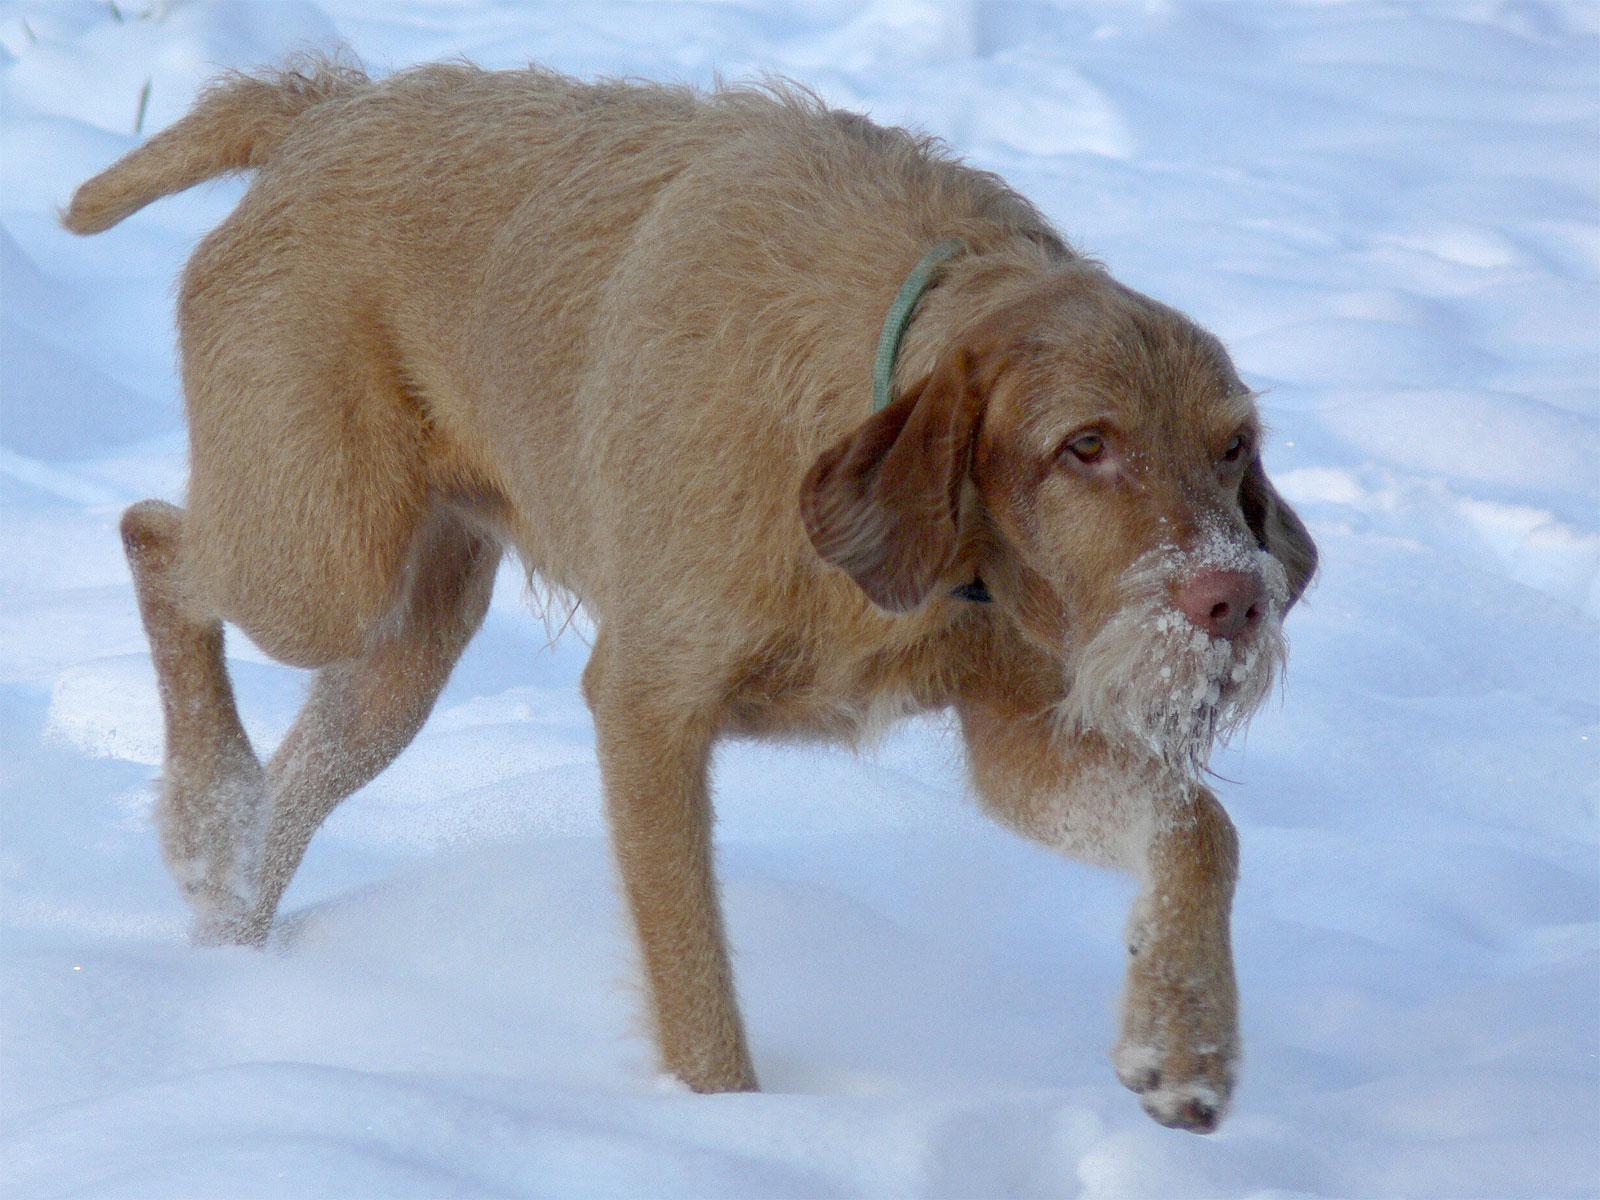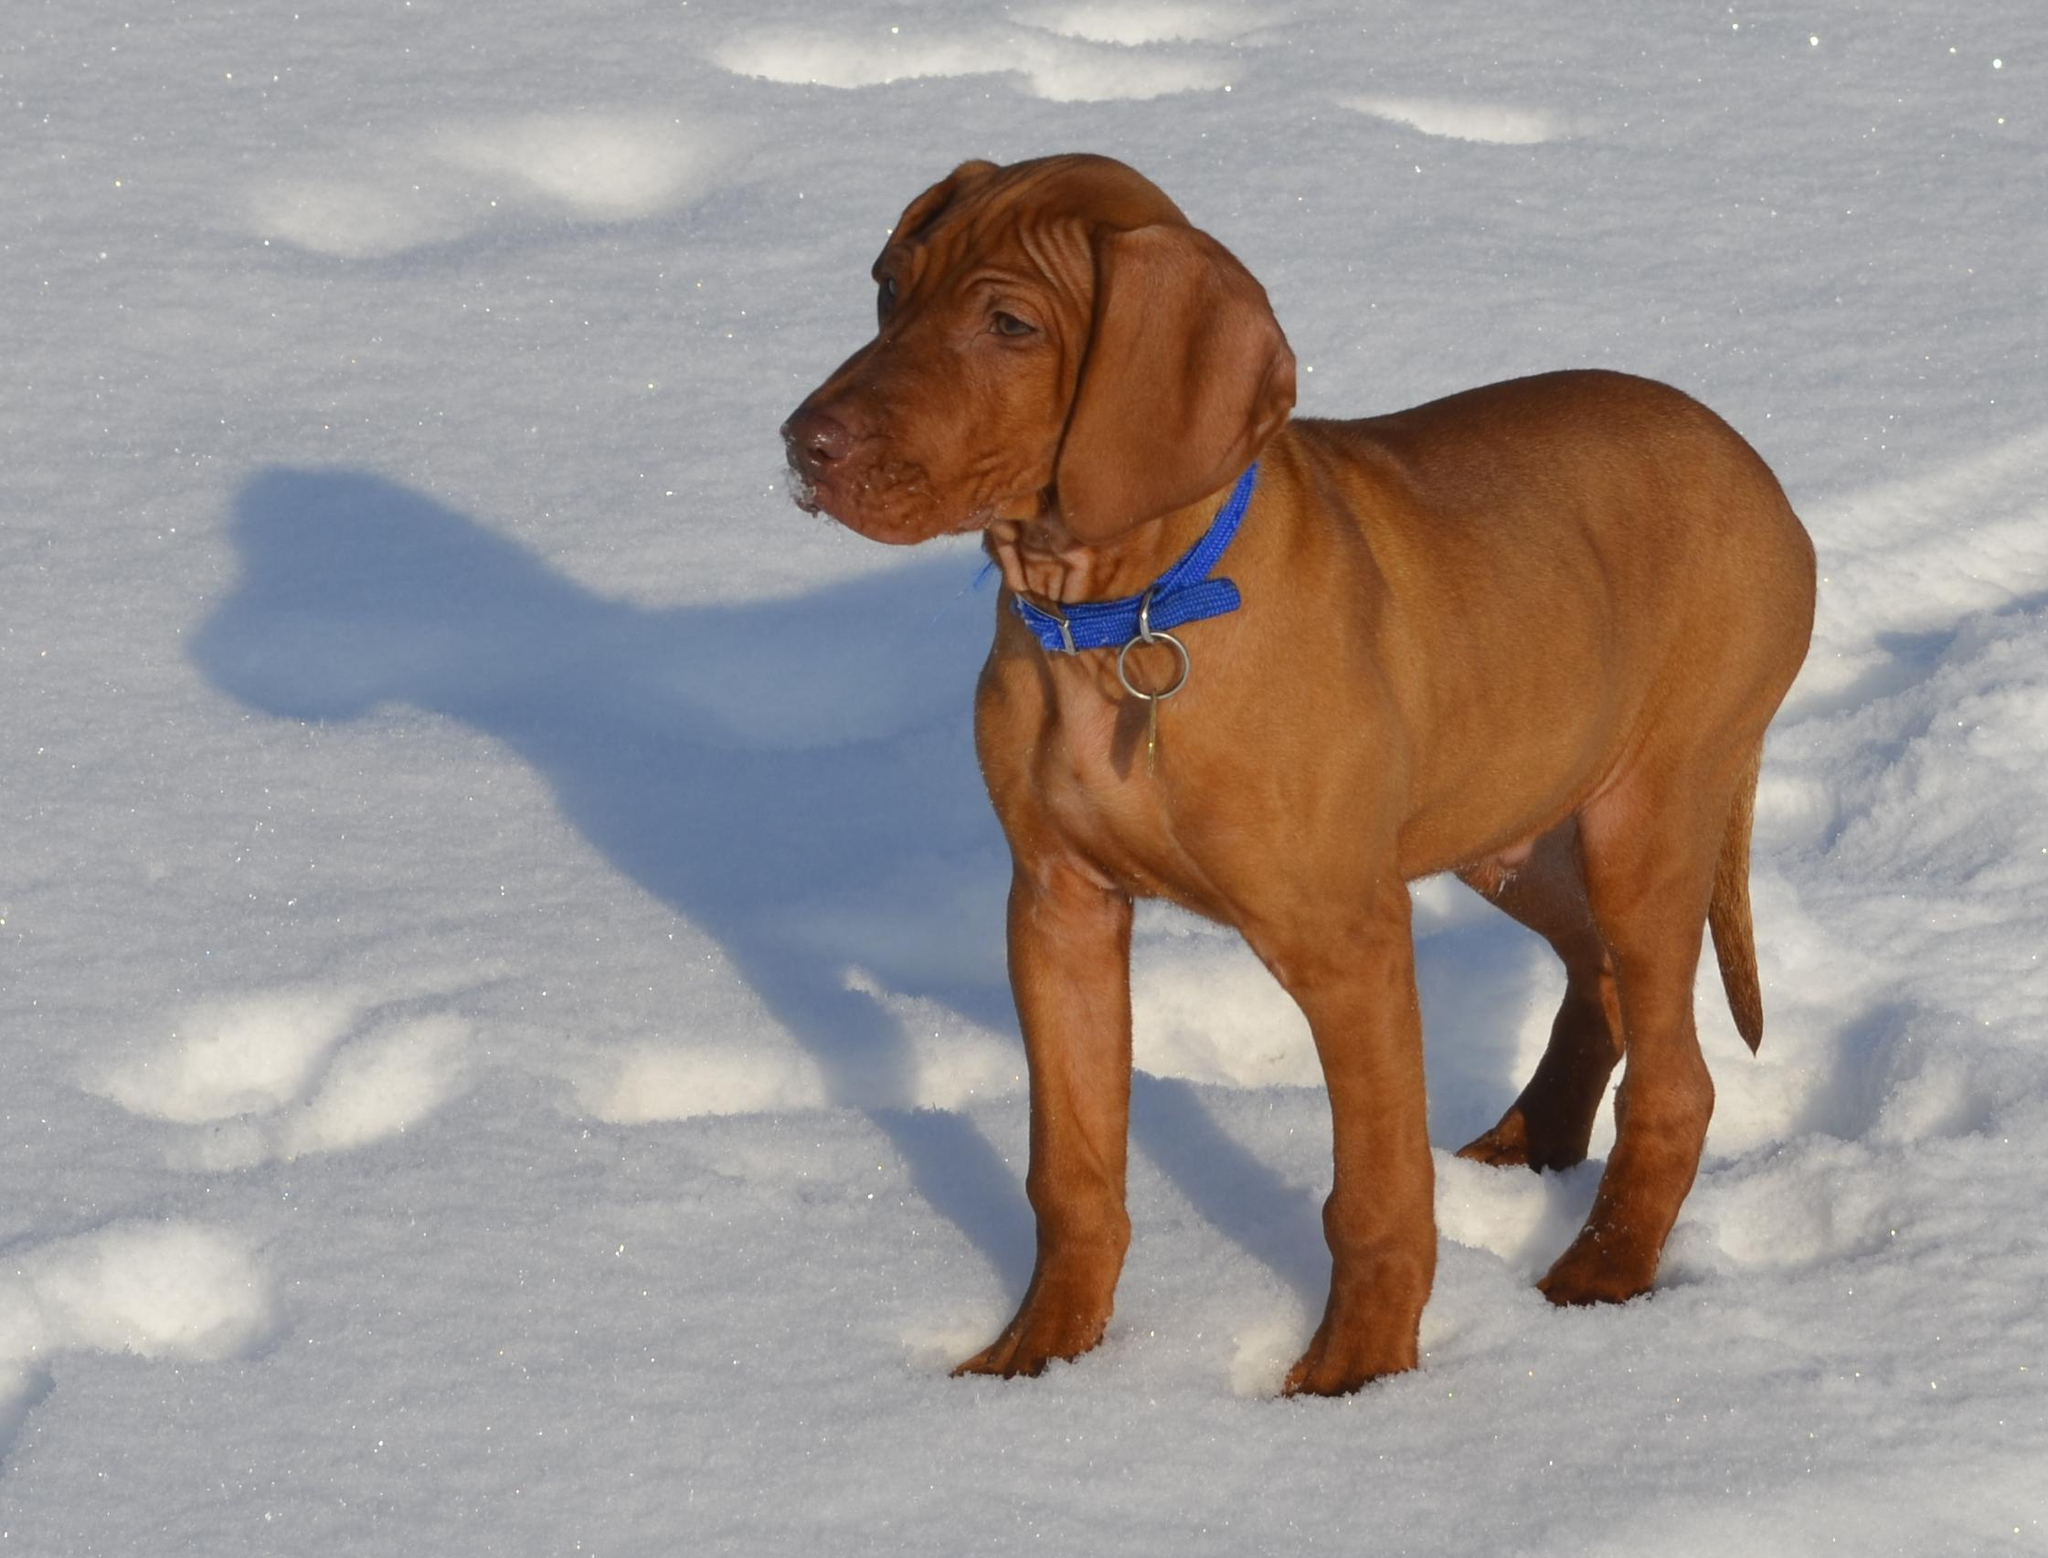The first image is the image on the left, the second image is the image on the right. Examine the images to the left and right. Is the description "One image shows a rightward-turned dog standing in profile with his tail out straight, and the other image features one puppy in a non-standing pose." accurate? Answer yes or no. No. The first image is the image on the left, the second image is the image on the right. Evaluate the accuracy of this statement regarding the images: "At least two dogs are outside.". Is it true? Answer yes or no. Yes. 